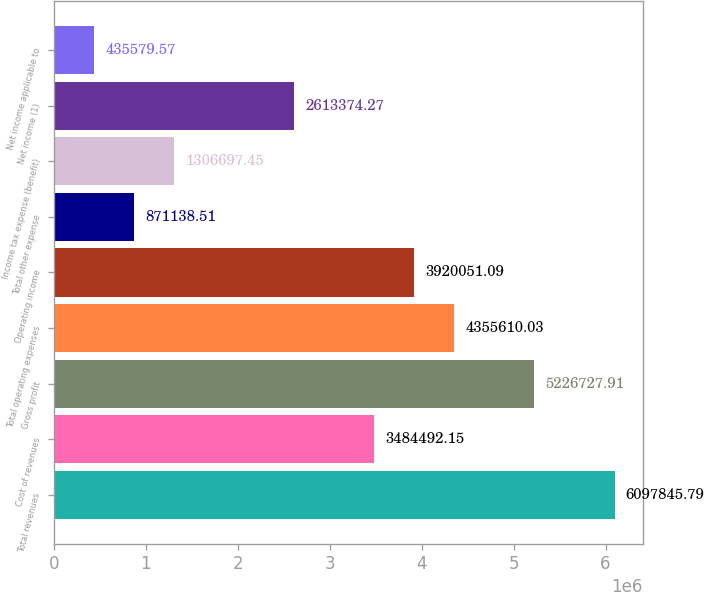Convert chart to OTSL. <chart><loc_0><loc_0><loc_500><loc_500><bar_chart><fcel>Total revenues<fcel>Cost of revenues<fcel>Gross profit<fcel>Total operating expenses<fcel>Operating income<fcel>Total other expense<fcel>Income tax expense (benefit)<fcel>Net income (1)<fcel>Net income applicable to<nl><fcel>6.09785e+06<fcel>3.48449e+06<fcel>5.22673e+06<fcel>4.35561e+06<fcel>3.92005e+06<fcel>871139<fcel>1.3067e+06<fcel>2.61337e+06<fcel>435580<nl></chart> 